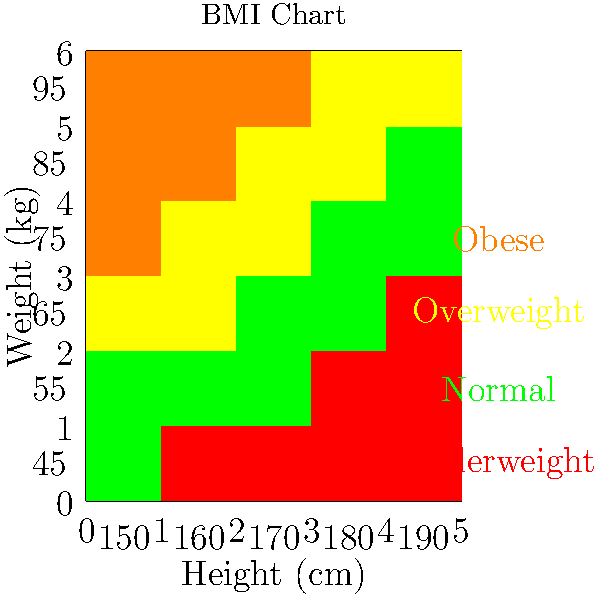Using the BMI chart provided, calculate the BMI for a client who is 170 cm tall and weighs 75 kg. Based on the result, what category does this client fall into? To calculate the BMI and determine the category, follow these steps:

1. Locate the client's height (170 cm) on the horizontal axis.
2. Find the client's weight (75 kg) on the vertical axis.
3. Identify the color of the box where these two values intersect.
4. The color corresponds to a BMI category:
   - Red: Underweight (BMI < 18.5)
   - Green: Normal weight (18.5 ≤ BMI < 25)
   - Yellow: Overweight (25 ≤ BMI < 30)
   - Orange: Obese (BMI ≥ 30)

5. For precise BMI calculation:
   $BMI = \frac{weight (kg)}{(height (m))^2}$
   $BMI = \frac{75}{(1.70)^2} = \frac{75}{2.89} \approx 25.95$

6. The intersection point on the chart is yellow, indicating "Overweight".

The calculated BMI of 25.95 confirms this categorization, as it falls within the overweight range (25 ≤ BMI < 30).
Answer: Overweight (BMI ≈ 25.95) 